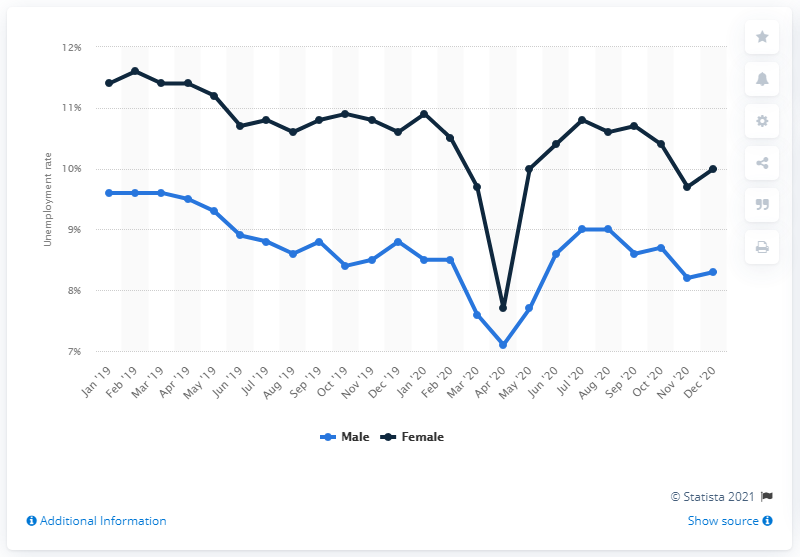Point out several critical features in this image. In December of 2020, the unemployment rate for women in Italy was 10%. In December of 2020, the unemployment rate for men in Italy was 8.3%. 